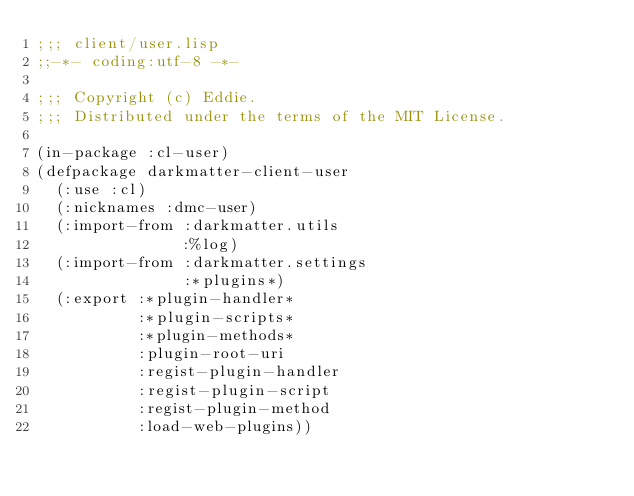Convert code to text. <code><loc_0><loc_0><loc_500><loc_500><_Lisp_>;;; client/user.lisp
;;-*- coding:utf-8 -*-

;;; Copyright (c) Eddie.
;;; Distributed under the terms of the MIT License.

(in-package :cl-user)
(defpackage darkmatter-client-user
  (:use :cl)
  (:nicknames :dmc-user)
  (:import-from :darkmatter.utils
                :%log)
  (:import-from :darkmatter.settings
                :*plugins*)
  (:export :*plugin-handler*
           :*plugin-scripts*
           :*plugin-methods*
           :plugin-root-uri
           :regist-plugin-handler
           :regist-plugin-script
           :regist-plugin-method
           :load-web-plugins))</code> 